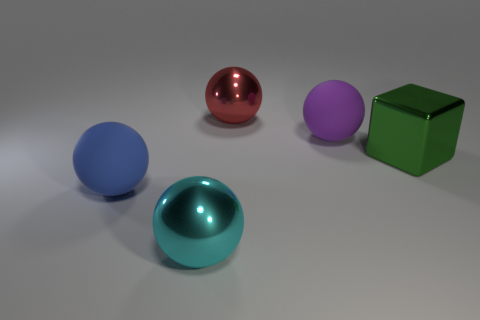Subtract all big red shiny balls. How many balls are left? 3 Add 1 large blue shiny cylinders. How many objects exist? 6 Subtract all cyan spheres. How many spheres are left? 3 Subtract all spheres. How many objects are left? 1 Subtract 4 balls. How many balls are left? 0 Subtract all gray balls. Subtract all purple cylinders. How many balls are left? 4 Subtract all purple balls. Subtract all cyan rubber cylinders. How many objects are left? 4 Add 5 purple spheres. How many purple spheres are left? 6 Add 5 large blue metallic objects. How many large blue metallic objects exist? 5 Subtract 0 red cubes. How many objects are left? 5 